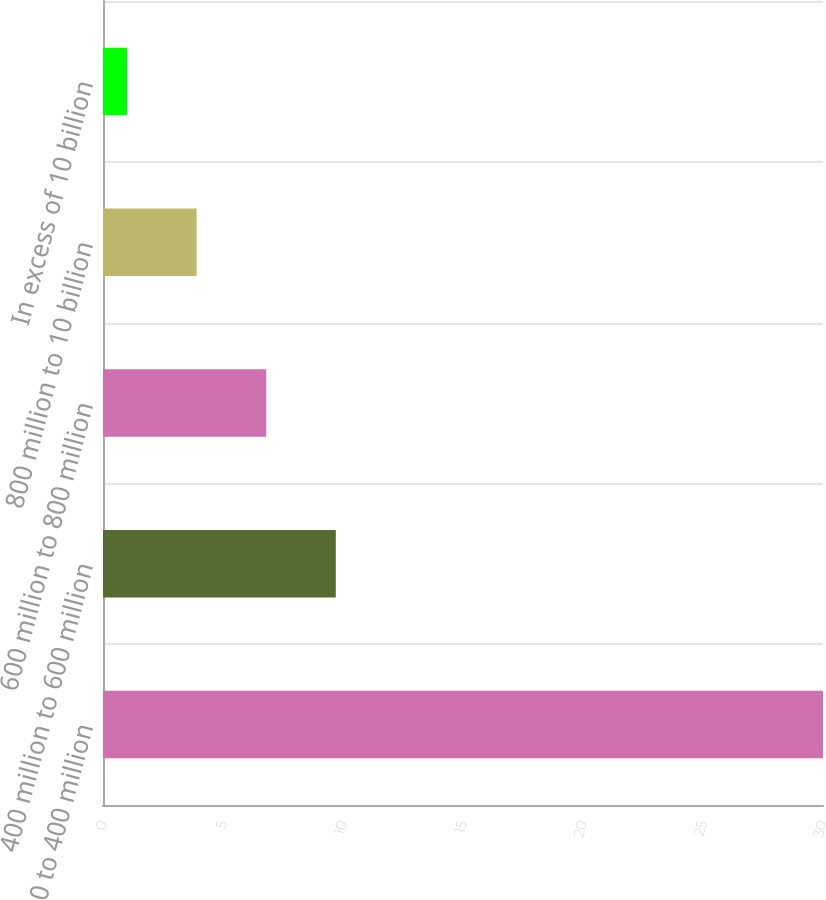<chart> <loc_0><loc_0><loc_500><loc_500><bar_chart><fcel>0 to 400 million<fcel>400 million to 600 million<fcel>600 million to 800 million<fcel>800 million to 10 billion<fcel>In excess of 10 billion<nl><fcel>30<fcel>9.7<fcel>6.8<fcel>3.9<fcel>1<nl></chart> 